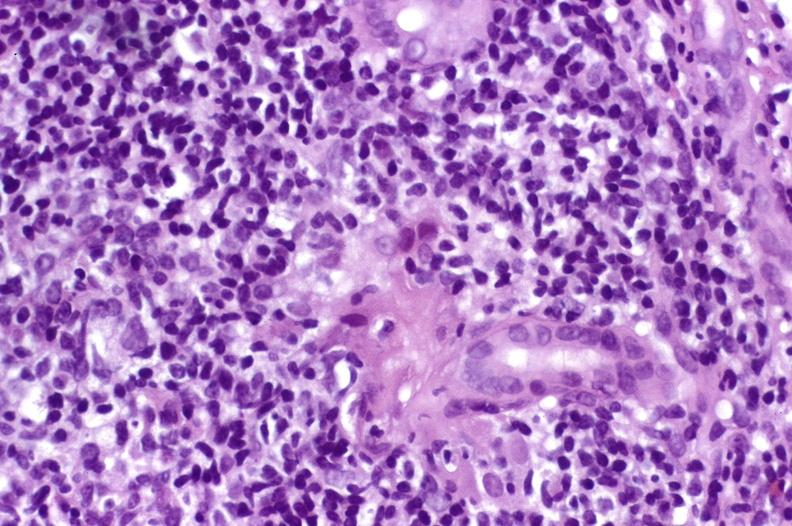s hepatobiliary present?
Answer the question using a single word or phrase. Yes 